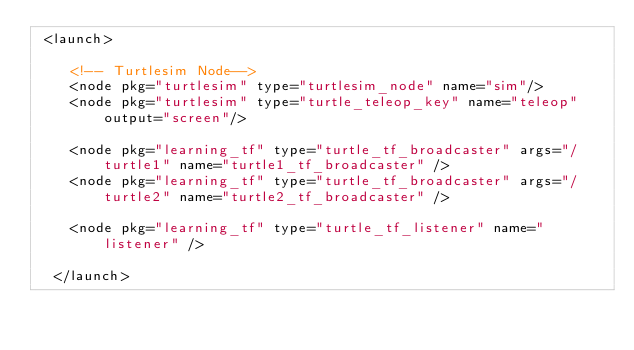Convert code to text. <code><loc_0><loc_0><loc_500><loc_500><_XML_> <launch>

    <!-- Turtlesim Node-->
    <node pkg="turtlesim" type="turtlesim_node" name="sim"/>
    <node pkg="turtlesim" type="turtle_teleop_key" name="teleop" output="screen"/>

    <node pkg="learning_tf" type="turtle_tf_broadcaster" args="/turtle1" name="turtle1_tf_broadcaster" />
    <node pkg="learning_tf" type="turtle_tf_broadcaster" args="/turtle2" name="turtle2_tf_broadcaster" />

    <node pkg="learning_tf" type="turtle_tf_listener" name="listener" />

  </launch>
</code> 